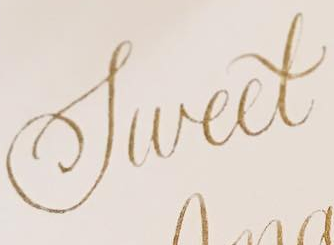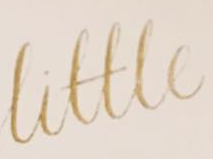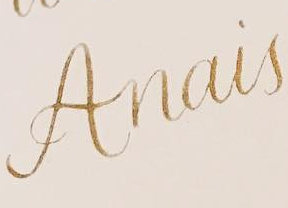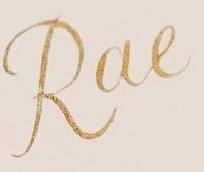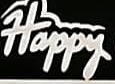Identify the words shown in these images in order, separated by a semicolon. Sweet; Little; Anais; Rae; Happy 